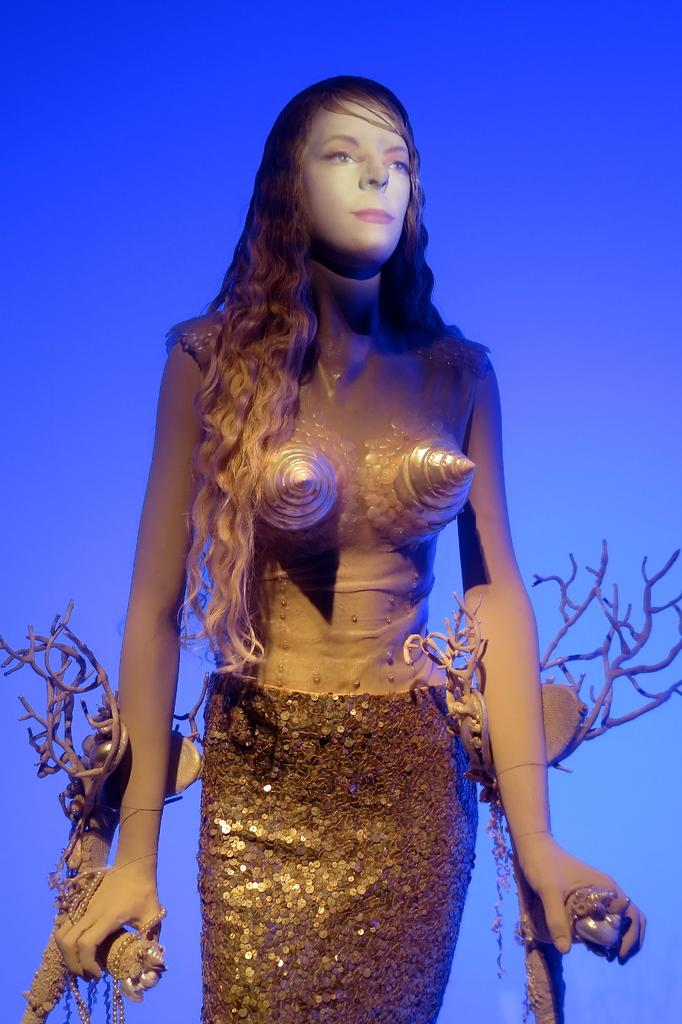Who is present in the image? There is a woman in the image. What is the woman doing in the image? The woman is standing in the image. What is the woman wearing in the image? The woman is wearing clothes in the image. What color is the background of the image? The background of the image is blue. What object can be seen in the image besides the woman? There is a chain visible in the image. What type of card can be seen being smashed by the woman in the image? There is no card present in the image, nor is the woman smashing anything. 